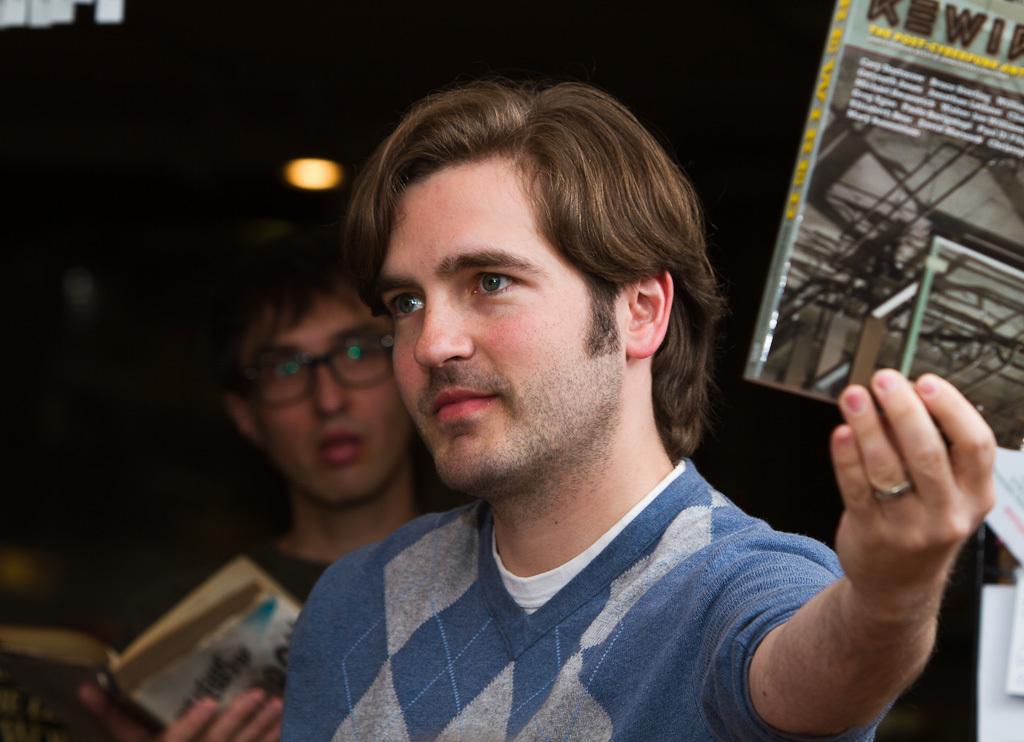Please provide a concise description of this image. In the foreground of the picture we can see a person holding a book. In the middle there is another person holding book. The background is dark. On the right there are some objects. 